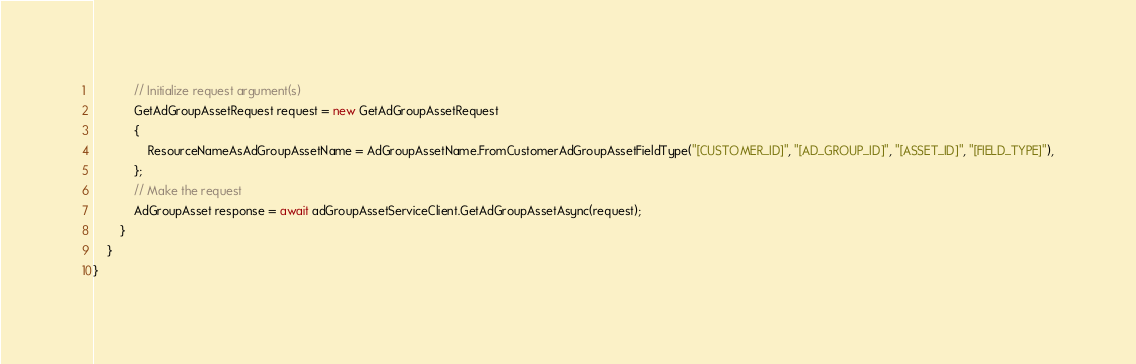<code> <loc_0><loc_0><loc_500><loc_500><_C#_>            // Initialize request argument(s)
            GetAdGroupAssetRequest request = new GetAdGroupAssetRequest
            {
                ResourceNameAsAdGroupAssetName = AdGroupAssetName.FromCustomerAdGroupAssetFieldType("[CUSTOMER_ID]", "[AD_GROUP_ID]", "[ASSET_ID]", "[FIELD_TYPE]"),
            };
            // Make the request
            AdGroupAsset response = await adGroupAssetServiceClient.GetAdGroupAssetAsync(request);
        }
    }
}
</code> 